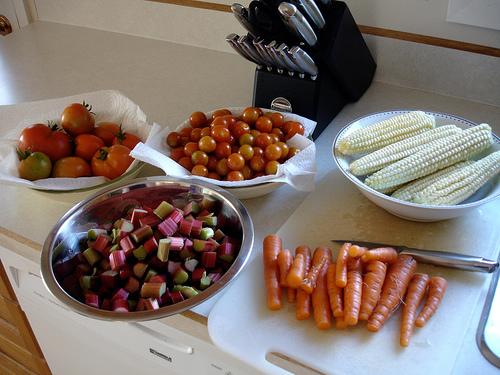What is in the silver bowl?
Give a very brief answer. Rhubarb. Are the tomatoes clean?
Write a very short answer. Yes. What is on the cutting board?
Write a very short answer. Carrots. Is this a display of healthy foods?
Write a very short answer. Yes. What is sitting on top of a cutting board?
Concise answer only. Carrots. How many compartments are on the metal plates?
Be succinct. 1. 